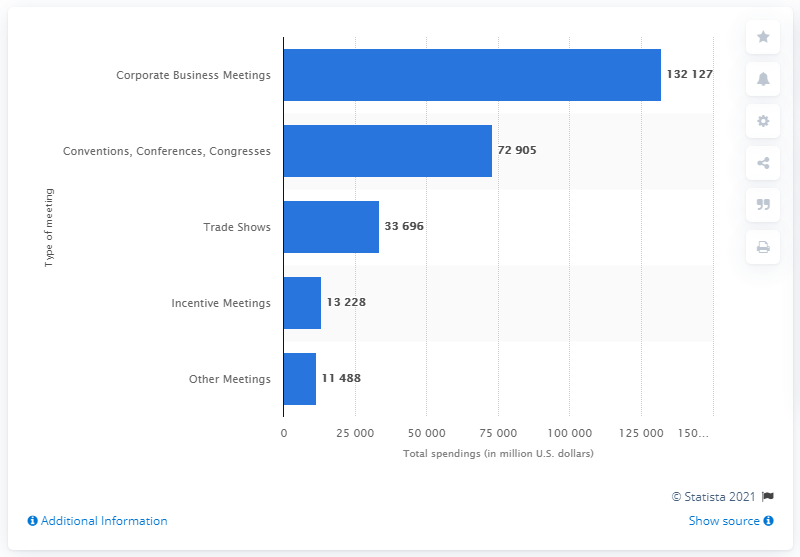Indicate a few pertinent items in this graphic. In 2009, the amount of money spent on corporate business meetings in the United States was approximately 132,127. 